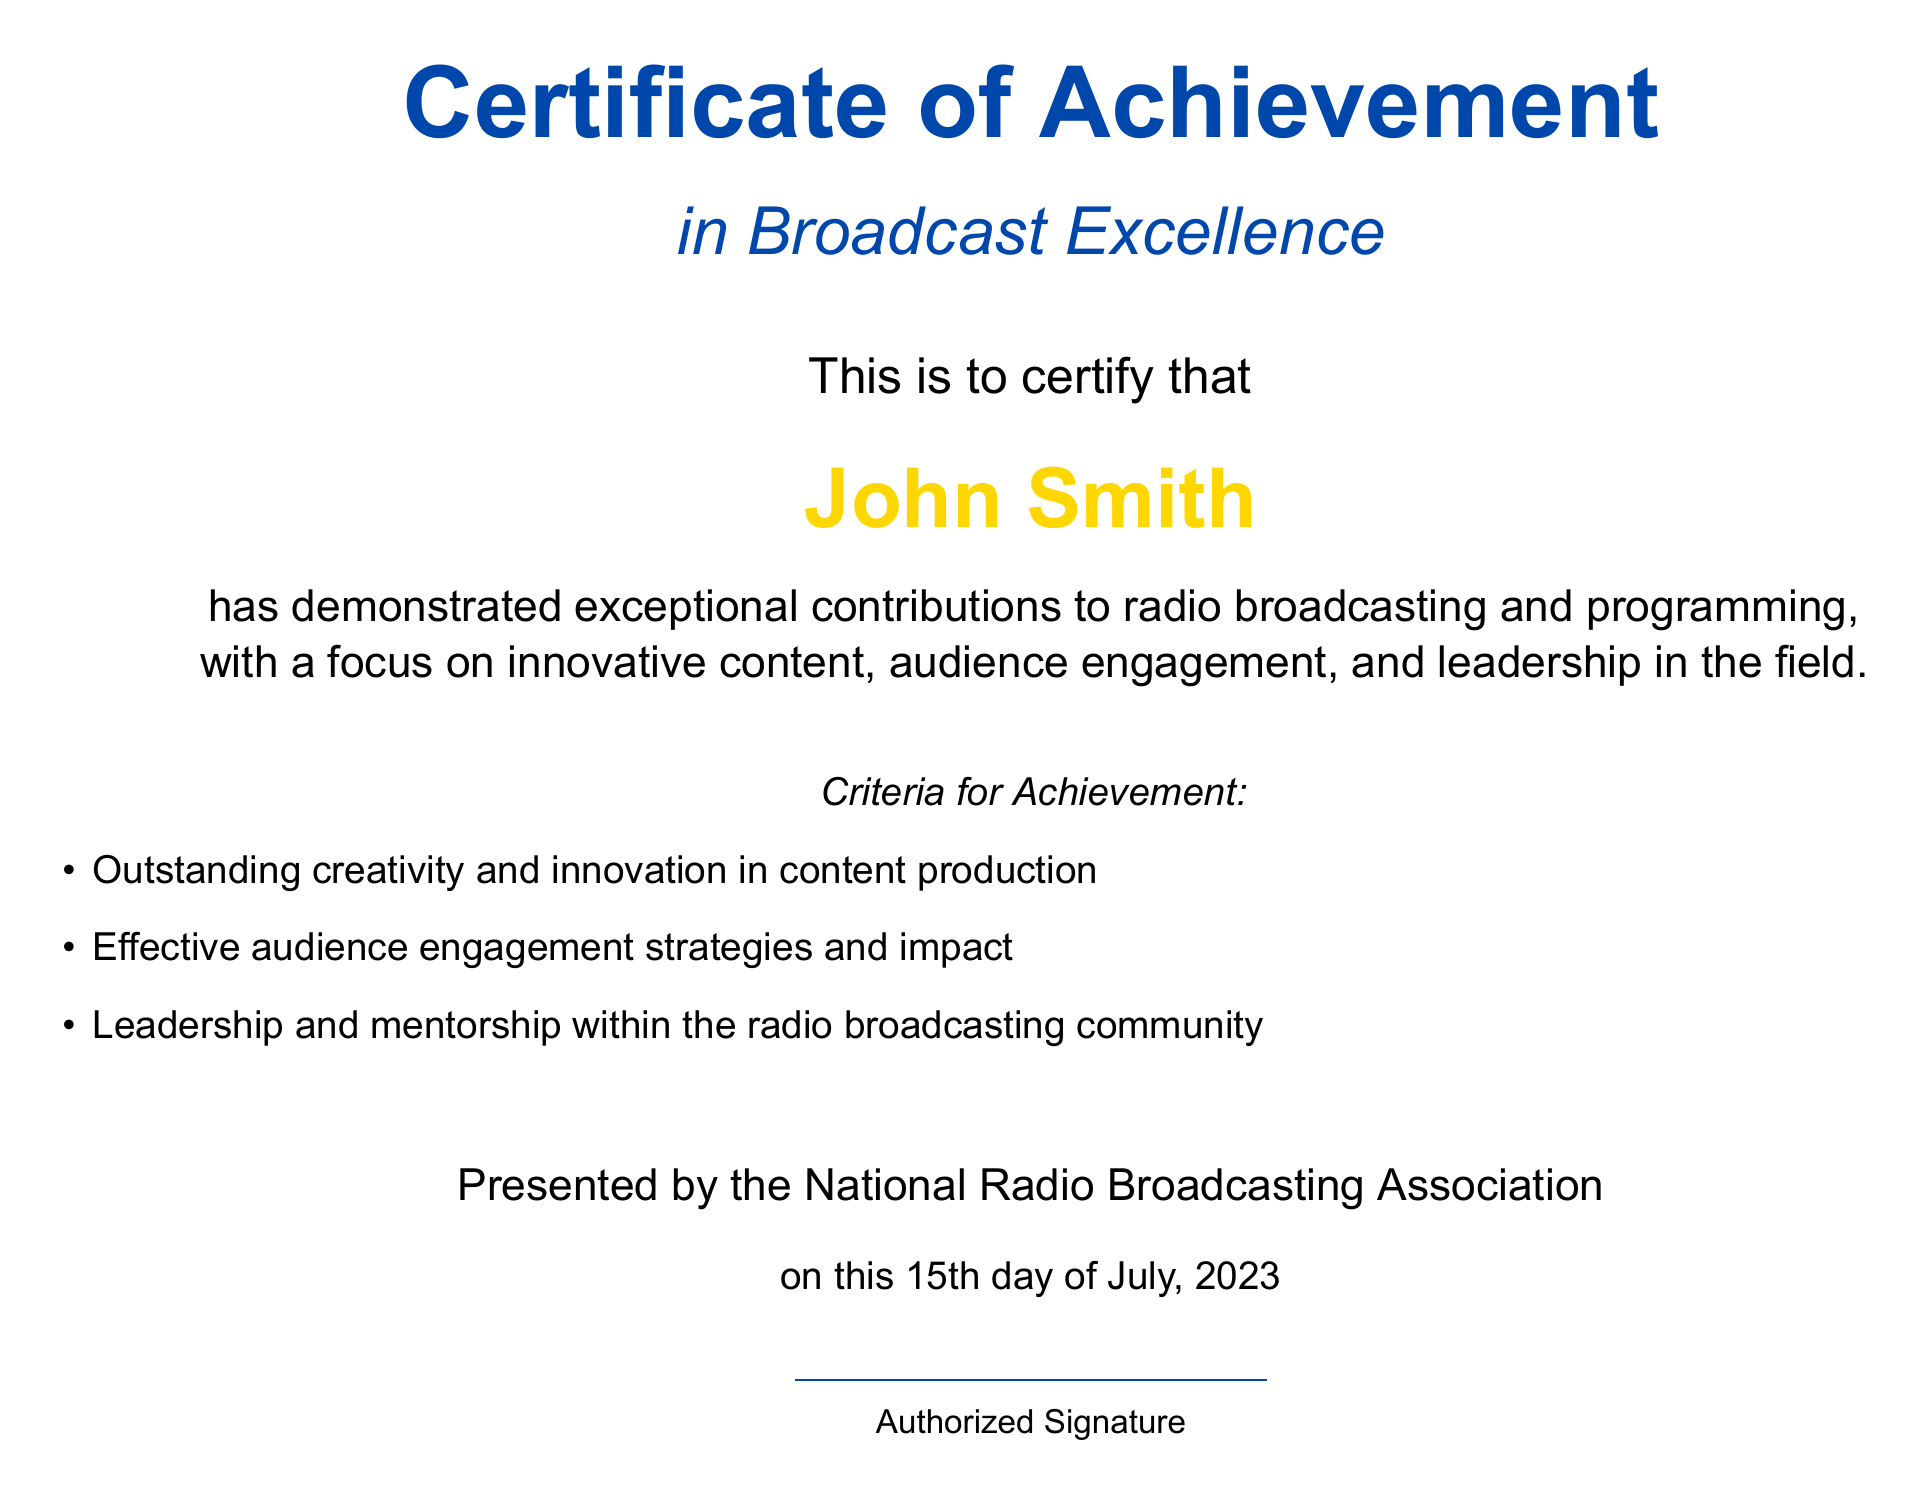What is the title of the certificate? The title of the certificate appears prominently at the top of the document and indicates the subject of recognition.
Answer: Certificate of Achievement in Broadcast Excellence Who is the recipient of the certificate? The recipient's name is featured in a larger font to highlight their achievement, appearing after the introductory text.
Answer: John Smith What is the issuing organization? The certificate states the organization that presented it, affirming the validity and recognition of the achievement.
Answer: National Radio Broadcasting Association What is the date of the certificate? The date is located near the signature area of the document, indicating when the certificate was awarded.
Answer: 15th day of July, 2023 What criteria were listed for achievement? The criteria for achievement are detailed in a bullet-point list, indicating the qualifications for receiving this honor.
Answer: Outstanding creativity and innovation in content production What color is used for the title text? The document uses a specific color scheme consistent with branding to elevate the certificate's visual appeal.
Answer: Radioblue What focus does the certificate emphasize? The emphasis is on specific aspects of radio broadcasting that align with the achievements recognized in the certificate.
Answer: Innovative content, audience engagement, and leadership What does the certificate primarily recognize? The main recognition pertains to contributions made in a particular professional context, which is indicated in the document text.
Answer: Exceptional contributions to radio broadcasting and programming 